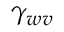Convert formula to latex. <formula><loc_0><loc_0><loc_500><loc_500>\gamma _ { w v }</formula> 